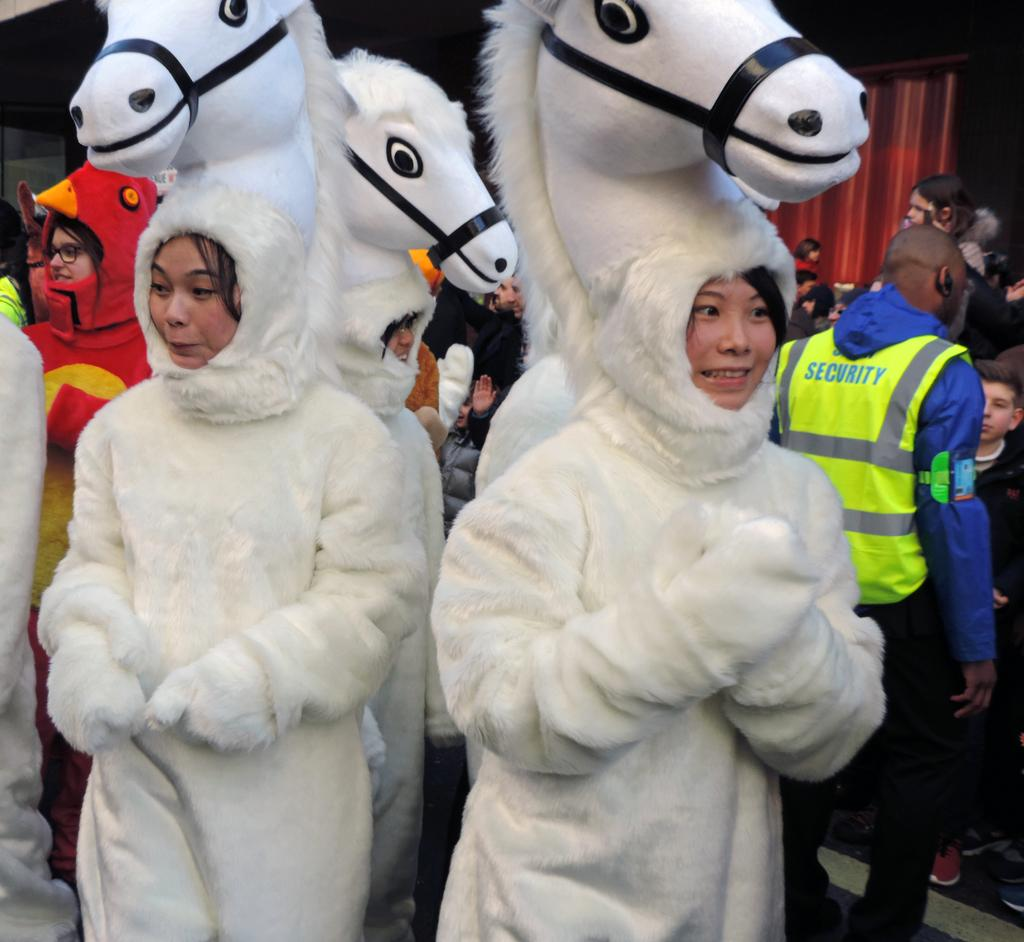How many people are in the group in the image? There is a group of people in the image, but the exact number is not specified. What are some people in the group wearing? Some people in the group are wearing costumes. Can you describe the object behind the people? There is a red object behind the people. What is the color of the background in the image? The background of the image is dark. What advice is the group of people giving to the current situation in the image? There is no indication in the image that the group of people is giving advice or discussing a current situation. 